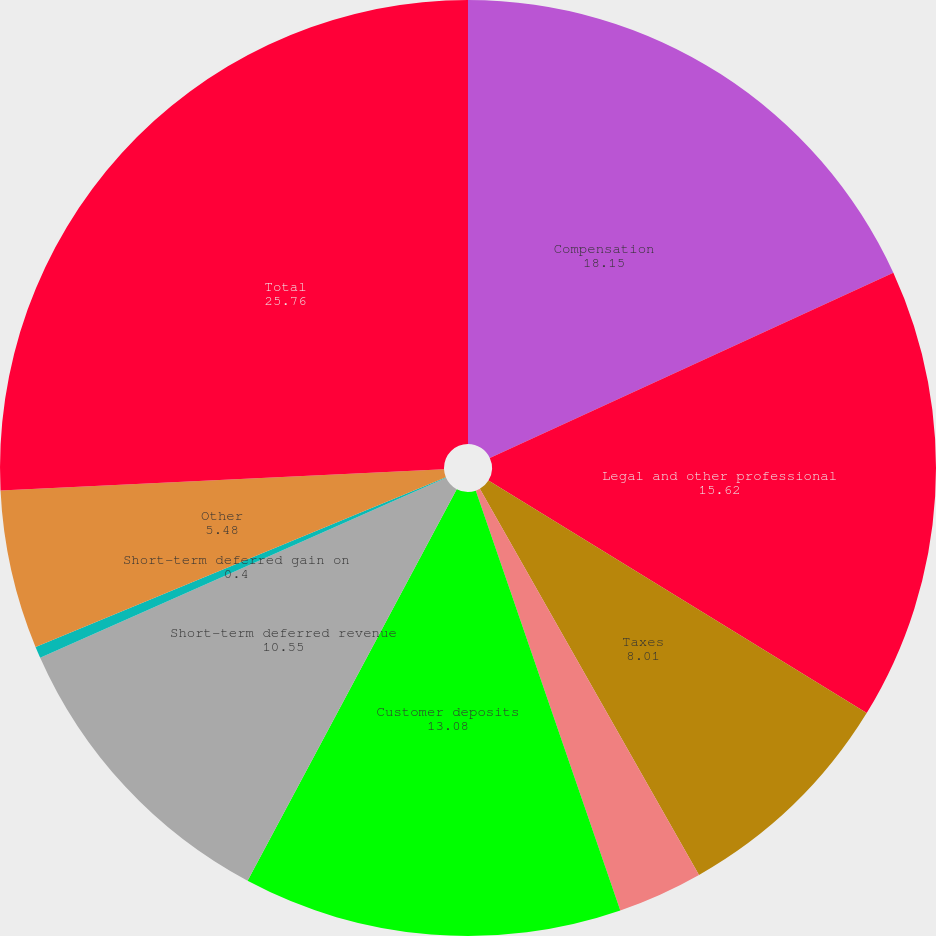<chart> <loc_0><loc_0><loc_500><loc_500><pie_chart><fcel>Compensation<fcel>Legal and other professional<fcel>Taxes<fcel>Reserve for product warranties<fcel>Customer deposits<fcel>Short-term deferred revenue<fcel>Short-term deferred gain on<fcel>Other<fcel>Total<nl><fcel>18.15%<fcel>15.62%<fcel>8.01%<fcel>2.94%<fcel>13.08%<fcel>10.55%<fcel>0.4%<fcel>5.48%<fcel>25.76%<nl></chart> 